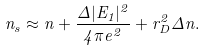Convert formula to latex. <formula><loc_0><loc_0><loc_500><loc_500>n _ { s } \approx n + \frac { \Delta | E _ { 1 } | ^ { 2 } } { 4 \pi e ^ { 2 } } + r _ { D } ^ { 2 } \Delta n .</formula> 